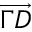Convert formula to latex. <formula><loc_0><loc_0><loc_500><loc_500>\overrightarrow { \Gamma D }</formula> 